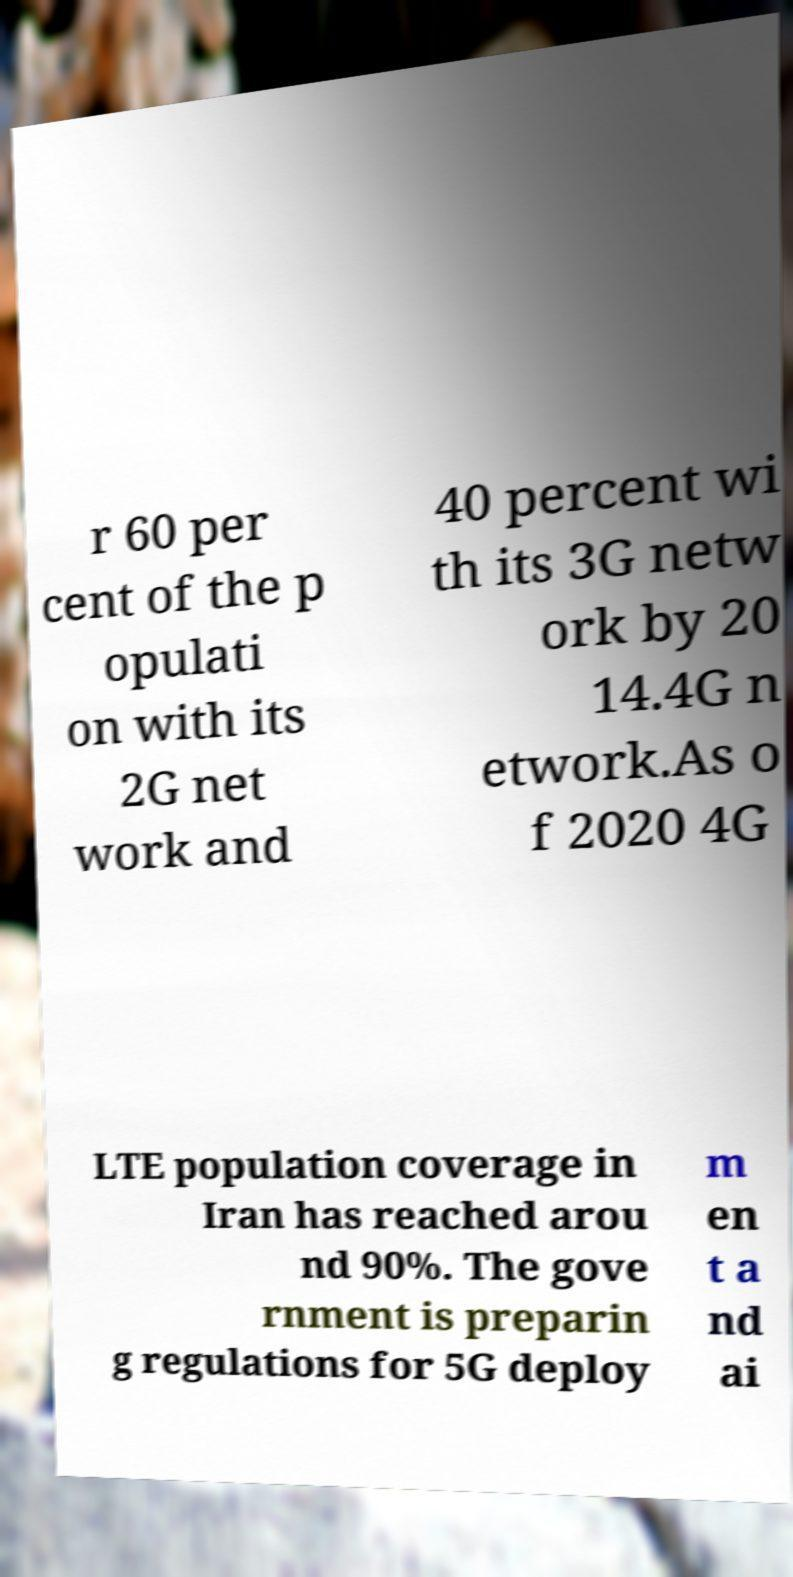Can you accurately transcribe the text from the provided image for me? r 60 per cent of the p opulati on with its 2G net work and 40 percent wi th its 3G netw ork by 20 14.4G n etwork.As o f 2020 4G LTE population coverage in Iran has reached arou nd 90%. The gove rnment is preparin g regulations for 5G deploy m en t a nd ai 